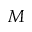<formula> <loc_0><loc_0><loc_500><loc_500>M</formula> 